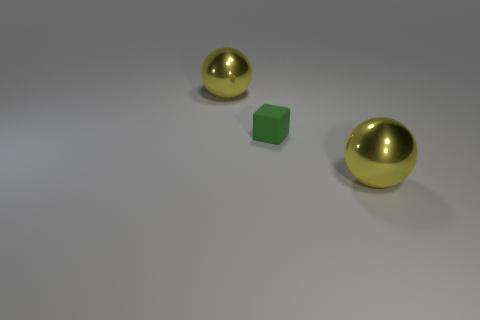What time of day or lighting conditions does the scene in the image suggest? The lighting conditions in the image appear to be neutral and artificial, akin to that in a studio setting. There are no strong shadows or indications of natural sunlight, and the overall illumination is even, likely from an overhead source. 